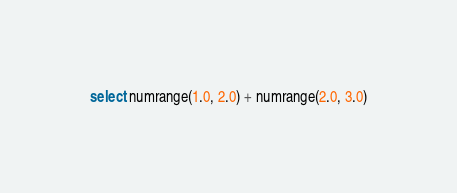<code> <loc_0><loc_0><loc_500><loc_500><_SQL_>select numrange(1.0, 2.0) + numrange(2.0, 3.0)
</code> 